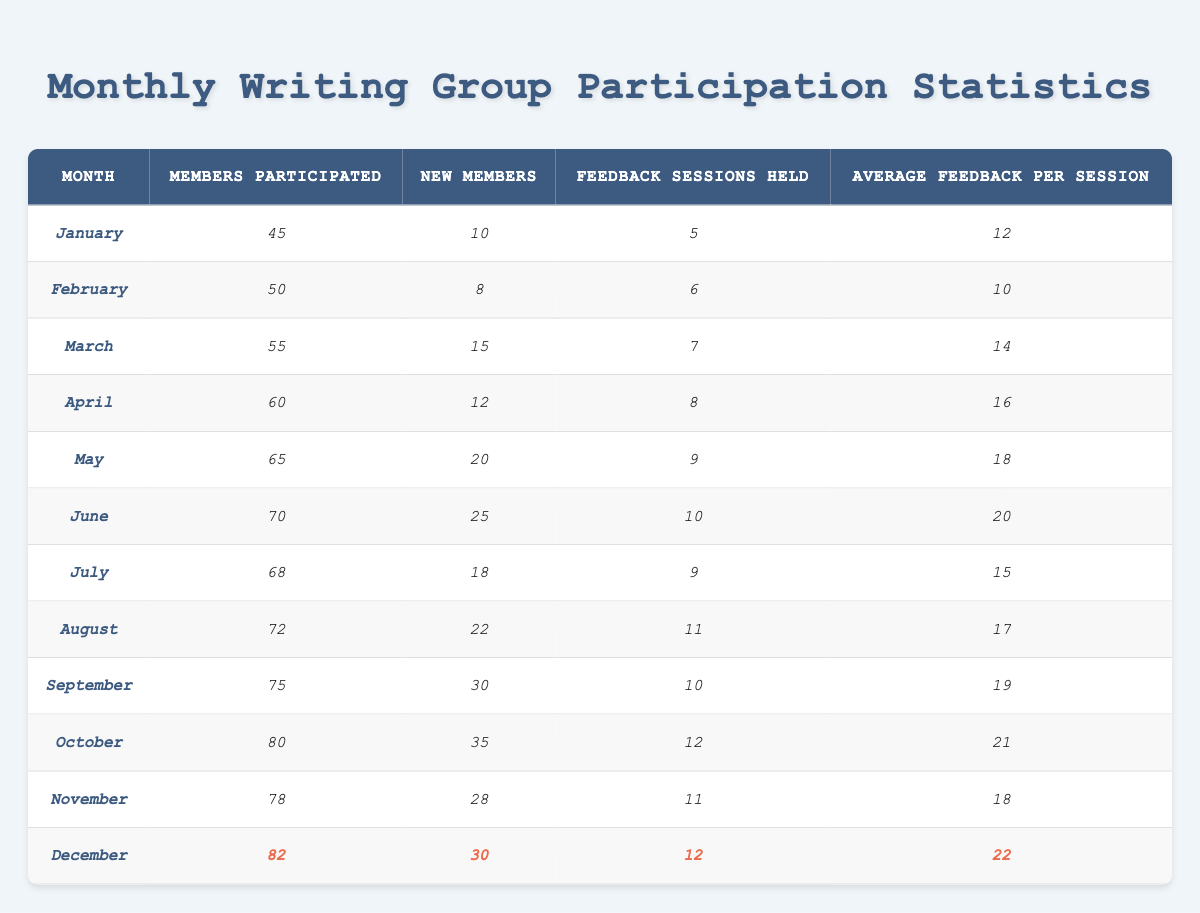What is the highest number of members that participated in a month? The highest value in the "Members Participated" column is found in December, where 82 members participated.
Answer: 82 Which month had the least number of new members? By looking at the "New Members" column, February has the smallest value with 8 new members.
Answer: 8 What was the average number of feedback sessions held per month over the year? Sum the total number of feedback sessions (5+6+7+8+9+10+9+11+10+12+11+12 = 12) and divide by the number of months (12). The average is 11.5.
Answer: 11.5 In which month did the group have the most feedback sessions held? By examining the "Feedback Sessions Held" column, the month of October had the most sessions with 12.
Answer: October What was the total increase in new members from January to December? Subtract the new members in January (10) from December (30). The increase is 30 - 10 = 20.
Answer: 20 What is the maximum average feedback received per session across all months? The maximum value in the "Average Feedback Per Session" column is 22 recorded in December.
Answer: 22 Did the number of members participating increase every month? By analyzing the "Members Participated" column, we see that the member count fluctuated; it decreased in July (68) from June (70), so not every month had an increase.
Answer: No How many more average feedback were received per session in October compared to January? The average feedback per session in October is 21 and in January, it is 12. The difference is 21 - 12 = 9.
Answer: 9 What percentage of new members joined in June compared to total members participated that month? There were 25 new members and 70 participated: (25/70) * 100 = 35.71%.
Answer: 35.71% Which three consecutive months saw the highest average feedback per session? Looking at the average feedback per session, December (22), October (21), and June (20) show the highest values when compared consecutively.
Answer: December, October, June 